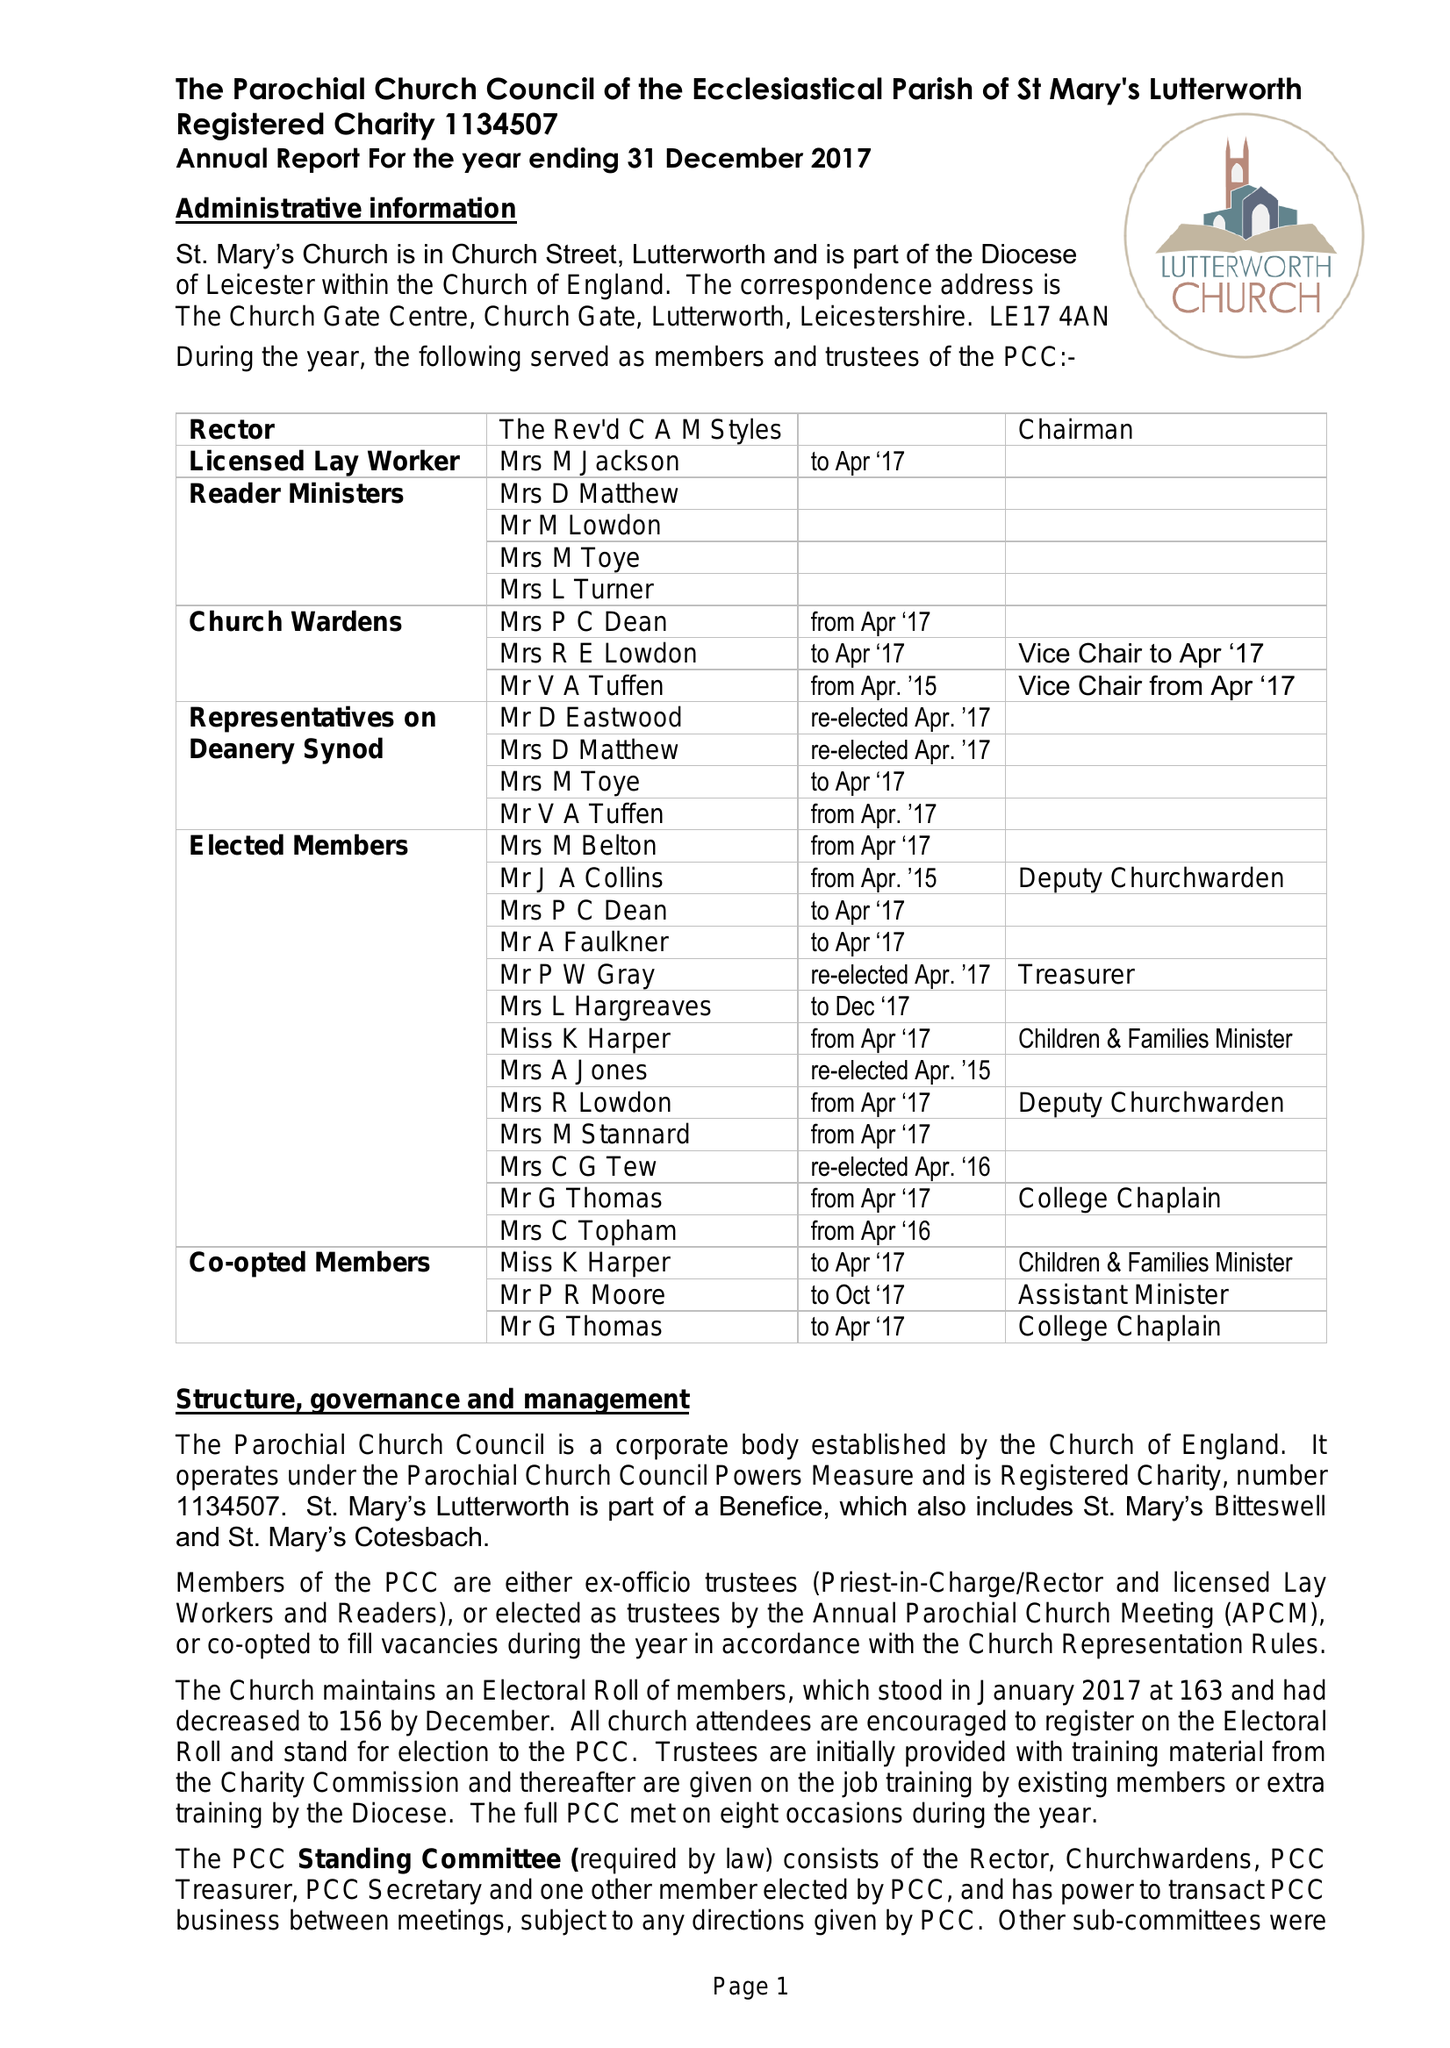What is the value for the income_annually_in_british_pounds?
Answer the question using a single word or phrase. 252868.00 